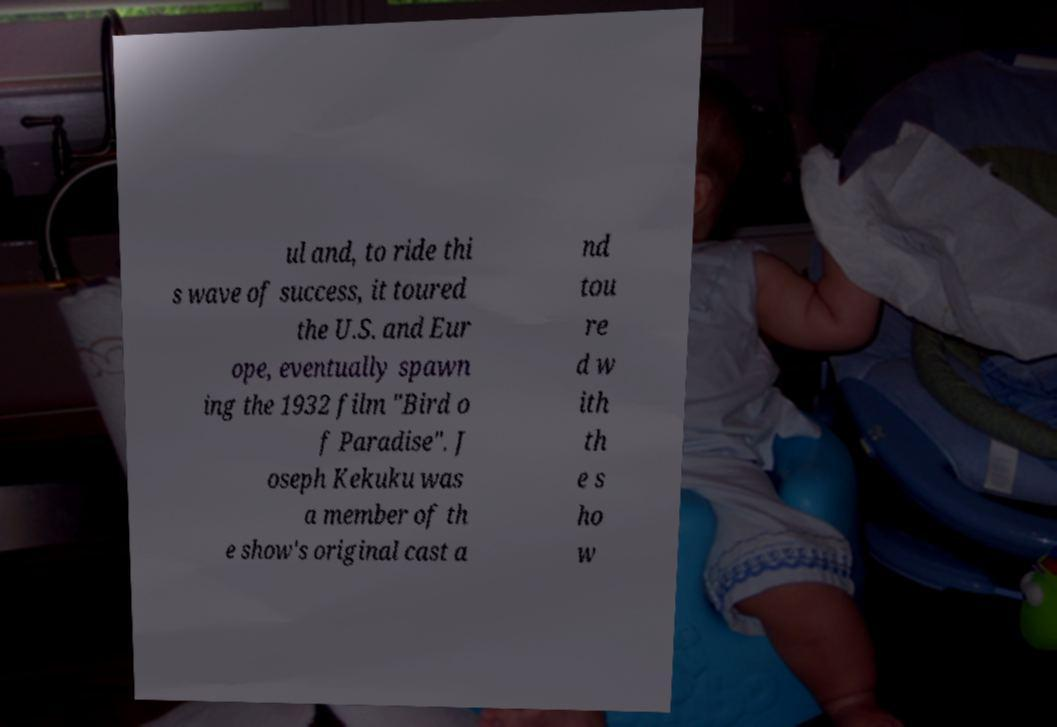Can you accurately transcribe the text from the provided image for me? ul and, to ride thi s wave of success, it toured the U.S. and Eur ope, eventually spawn ing the 1932 film "Bird o f Paradise". J oseph Kekuku was a member of th e show's original cast a nd tou re d w ith th e s ho w 